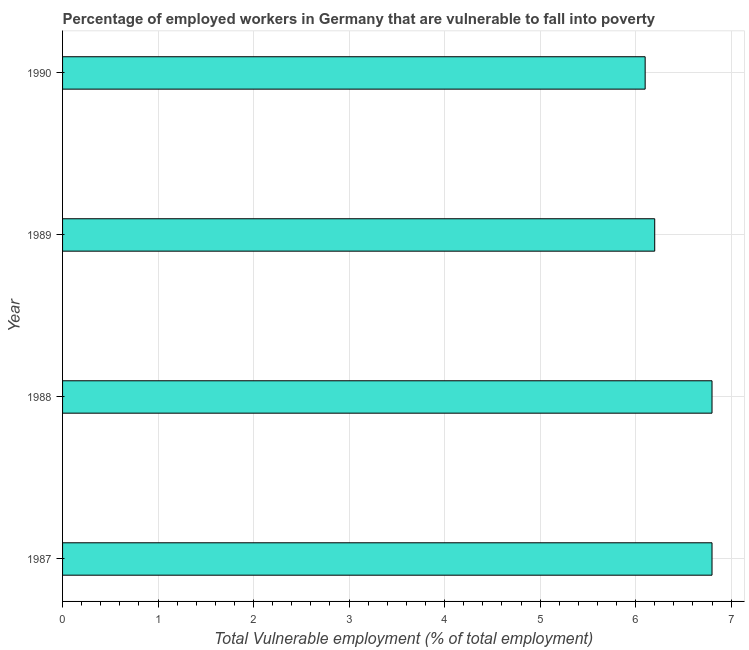Does the graph contain grids?
Provide a succinct answer. Yes. What is the title of the graph?
Your answer should be very brief. Percentage of employed workers in Germany that are vulnerable to fall into poverty. What is the label or title of the X-axis?
Offer a terse response. Total Vulnerable employment (% of total employment). What is the label or title of the Y-axis?
Your response must be concise. Year. What is the total vulnerable employment in 1989?
Keep it short and to the point. 6.2. Across all years, what is the maximum total vulnerable employment?
Provide a short and direct response. 6.8. Across all years, what is the minimum total vulnerable employment?
Provide a short and direct response. 6.1. In which year was the total vulnerable employment minimum?
Your response must be concise. 1990. What is the sum of the total vulnerable employment?
Offer a very short reply. 25.9. What is the average total vulnerable employment per year?
Make the answer very short. 6.47. What is the median total vulnerable employment?
Your response must be concise. 6.5. What is the ratio of the total vulnerable employment in 1989 to that in 1990?
Keep it short and to the point. 1.02. Is the total vulnerable employment in 1987 less than that in 1988?
Offer a very short reply. No. Is the difference between the total vulnerable employment in 1988 and 1990 greater than the difference between any two years?
Your answer should be compact. Yes. What is the difference between the highest and the lowest total vulnerable employment?
Keep it short and to the point. 0.7. Are all the bars in the graph horizontal?
Ensure brevity in your answer.  Yes. How many years are there in the graph?
Give a very brief answer. 4. What is the Total Vulnerable employment (% of total employment) in 1987?
Offer a very short reply. 6.8. What is the Total Vulnerable employment (% of total employment) in 1988?
Your answer should be very brief. 6.8. What is the Total Vulnerable employment (% of total employment) of 1989?
Provide a succinct answer. 6.2. What is the Total Vulnerable employment (% of total employment) of 1990?
Your answer should be very brief. 6.1. What is the difference between the Total Vulnerable employment (% of total employment) in 1987 and 1989?
Your response must be concise. 0.6. What is the difference between the Total Vulnerable employment (% of total employment) in 1987 and 1990?
Ensure brevity in your answer.  0.7. What is the difference between the Total Vulnerable employment (% of total employment) in 1989 and 1990?
Provide a short and direct response. 0.1. What is the ratio of the Total Vulnerable employment (% of total employment) in 1987 to that in 1988?
Offer a terse response. 1. What is the ratio of the Total Vulnerable employment (% of total employment) in 1987 to that in 1989?
Give a very brief answer. 1.1. What is the ratio of the Total Vulnerable employment (% of total employment) in 1987 to that in 1990?
Your response must be concise. 1.11. What is the ratio of the Total Vulnerable employment (% of total employment) in 1988 to that in 1989?
Your answer should be compact. 1.1. What is the ratio of the Total Vulnerable employment (% of total employment) in 1988 to that in 1990?
Your response must be concise. 1.11. What is the ratio of the Total Vulnerable employment (% of total employment) in 1989 to that in 1990?
Keep it short and to the point. 1.02. 